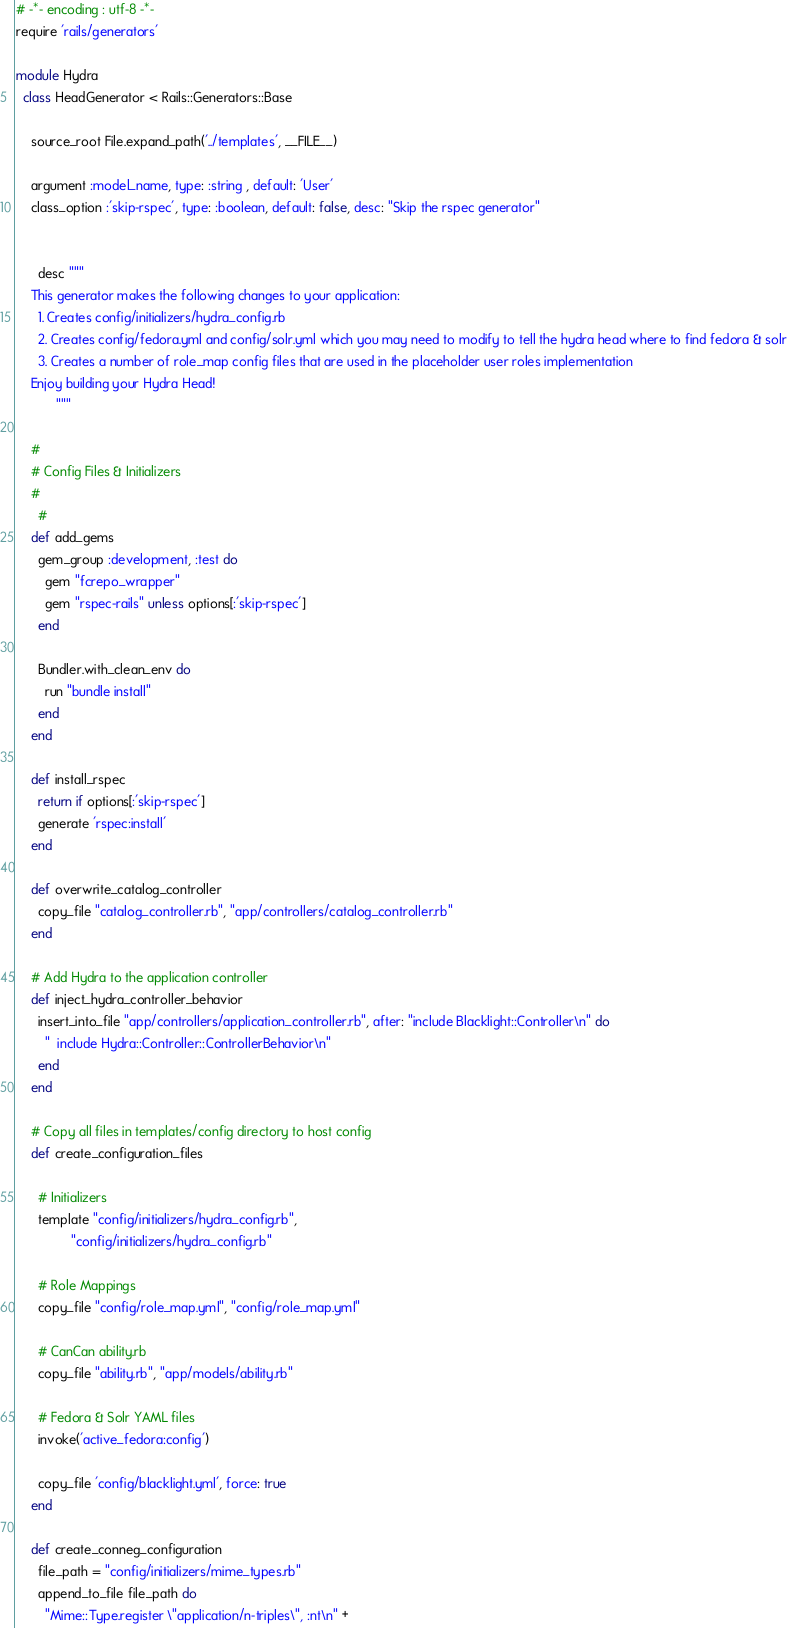<code> <loc_0><loc_0><loc_500><loc_500><_Ruby_># -*- encoding : utf-8 -*-
require 'rails/generators'

module Hydra
  class HeadGenerator < Rails::Generators::Base

    source_root File.expand_path('../templates', __FILE__)

    argument :model_name, type: :string , default: 'User'
    class_option :'skip-rspec', type: :boolean, default: false, desc: "Skip the rspec generator"


      desc """
    This generator makes the following changes to your application:
      1. Creates config/initializers/hydra_config.rb
      2. Creates config/fedora.yml and config/solr.yml which you may need to modify to tell the hydra head where to find fedora & solr
      3. Creates a number of role_map config files that are used in the placeholder user roles implementation
    Enjoy building your Hydra Head!
           """

    #
    # Config Files & Initializers
    #
      #
    def add_gems
      gem_group :development, :test do
        gem "fcrepo_wrapper"
        gem "rspec-rails" unless options[:'skip-rspec']
      end

      Bundler.with_clean_env do
        run "bundle install"
      end
    end

    def install_rspec
      return if options[:'skip-rspec']
      generate 'rspec:install'
    end

    def overwrite_catalog_controller
      copy_file "catalog_controller.rb", "app/controllers/catalog_controller.rb"
    end

    # Add Hydra to the application controller
    def inject_hydra_controller_behavior
      insert_into_file "app/controllers/application_controller.rb", after: "include Blacklight::Controller\n" do
        "  include Hydra::Controller::ControllerBehavior\n"
      end
    end

    # Copy all files in templates/config directory to host config
    def create_configuration_files

      # Initializers
      template "config/initializers/hydra_config.rb",
               "config/initializers/hydra_config.rb"

      # Role Mappings
      copy_file "config/role_map.yml", "config/role_map.yml"

      # CanCan ability.rb
      copy_file "ability.rb", "app/models/ability.rb"

      # Fedora & Solr YAML files
      invoke('active_fedora:config')

      copy_file 'config/blacklight.yml', force: true
    end

    def create_conneg_configuration
      file_path = "config/initializers/mime_types.rb"
      append_to_file file_path do
        "Mime::Type.register \"application/n-triples\", :nt\n" +</code> 